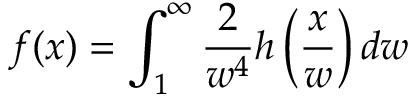<formula> <loc_0><loc_0><loc_500><loc_500>f ( x ) = \int _ { 1 } ^ { \infty } { \frac { 2 } { w ^ { 4 } } } h \left ( { \frac { x } { w } } \right ) d w</formula> 